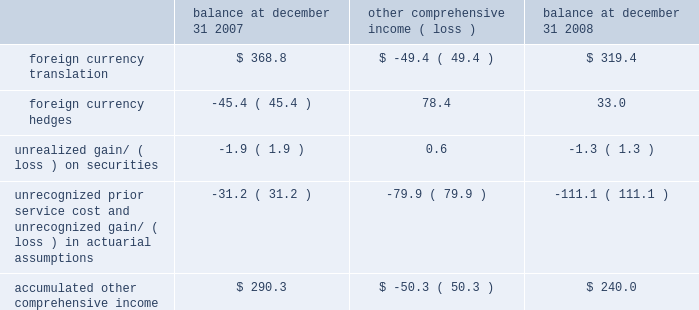The years ended december 31 , 2008 , 2007 and 2006 , due to ineffectiveness and amounts excluded from the assessment of hedge effectiveness , was not significant .
For contracts outstanding at december 31 , 2008 , we have an obligation to purchase u.s .
Dollars and sell euros , japanese yen , british pounds , canadian dollars , australian dollars and korean won and purchase swiss francs and sell u.s .
Dollars at set maturity dates ranging from january 2009 through june 2011 .
The notional amounts of outstanding forward contracts entered into with third parties to purchase u.s .
Dollars at december 31 , 2008 were $ 1343.0 million .
The notional amounts of outstanding forward contracts entered into with third parties to purchase swiss francs at december 31 , 2008 were $ 207.5 million .
The fair value of outstanding derivative instruments recorded on the balance sheet at december 31 , 2008 , together with settled derivatives where the hedged item has not yet affected earnings , was a net unrealized gain of $ 32.7 million , or $ 33.0 million net of taxes , which is deferred in other comprehensive income , of which $ 16.4 million , or $ 17.9 million , net of taxes , is expected to be reclassified to earnings over the next twelve months .
We also enter into foreign currency forward exchange contracts with terms of one month to manage currency exposures for assets and liabilities denominated in a currency other than an entity 2019s functional currency .
As a result , any foreign currency remeasurement gains/losses recognized in earnings under sfas no .
52 , 201cforeign currency translation , 201d are generally offset with gains/losses on the foreign currency forward exchange contracts in the same reporting period .
Other comprehensive income 2013 other comprehensive income refers to revenues , expenses , gains and losses that under generally accepted accounting principles are included in comprehensive income but are excluded from net earnings as these amounts are recorded directly as an adjustment to stockholders 2019 equity .
Other comprehensive income is comprised of foreign currency translation adjustments , unrealized foreign currency hedge gains and losses , unrealized gains and losses on available-for-sale securities and amortization of prior service costs and unrecognized gains and losses in actuarial assumptions .
In 2006 we adopted sfas 158 , 201cemployers 2019 accounting for defined benefit pension and other postretirement plans 2013 an amendment of fasb statements no .
87 , 88 , 106 and 132 ( r ) . 201d this statement required recognition of the funded status of our benefit plans in the statement of financial position and recognition of certain deferred gains or losses in other comprehensive income .
We recorded an unrealized loss of $ 35.4 million in other comprehensive income during 2006 related to the adoption of sfas 158 .
The components of accumulated other comprehensive income are as follows ( in millions ) : balance at december 31 , comprehensive income ( loss ) balance at december 31 .
During 2008 , we reclassified an investment previously accounted for under the equity method to an available-for-sale investment as we no longer exercised significant influence over the third-party investee .
The investment was marked-to- market in accordance with sfas 115 , 201caccounting for certain investments in debt and equity securities , 201d resulting in a net unrealized gain of $ 23.8 million recorded in other comprehensive income for 2008 .
This unrealized gain was reclassified to the income statement when we sold this investment in 2008 for total proceeds of $ 54.9 million and a gross realized gain of $ 38.8 million included in interest and other income .
The basis of these securities was determined based on the consideration paid at the time of acquisition .
Treasury stock 2013 we account for repurchases of common stock under the cost method and present treasury stock as a reduction of shareholders equity .
We may reissue common stock held in treasury only for limited purposes .
Accounting pronouncements 2013 in september 2006 , the fasb issued sfas no .
157 , 201cfair value measurements , 201d which defines fair value , establishes a framework for measuring fair value in generally accepted accounting principles and expands disclosures about fair value measurements .
This statement does not require any new fair value measurements , but provides guidance on how to measure fair value by providing a fair value hierarchy used to classify the source of the information .
Sfas no .
157 is effective for financial statements issued for fiscal years beginning after november 15 , 2007 and interim periods within those fiscal years .
In february 2008 , the fasb issued fasb staff position ( fsp ) no .
Sfas 157-2 , which delays the effective date of certain provisions of sfas no .
157 relating to non-financial assets and liabilities measured at fair value on a non-recurring basis until fiscal years beginning after november 15 , 2008 .
The full adoption of sfas no .
157 is not expected to have a material impact on our consolidated financial statements or results of operations .
Z i m m e r h o l d i n g s , i n c .
2 0 0 8 f o r m 1 0 - k a n n u a l r e p o r t notes to consolidated financial statements ( continued ) %%transmsg*** transmitting job : c48761 pcn : 046000000 ***%%pcmsg|46 |00009|yes|no|02/24/2009 19:24|0|0|page is valid , no graphics -- color : d| .
What would the unrealized gain/ ( loss ) on securities in millions have been in 2008 without the reclassification of an investment previously accounted for under the equity method to an available-for-sale investment? 
Rationale: looking to see the affect of the one off reclassification
Computations: (-1.3 - 23.8)
Answer: -25.1. 